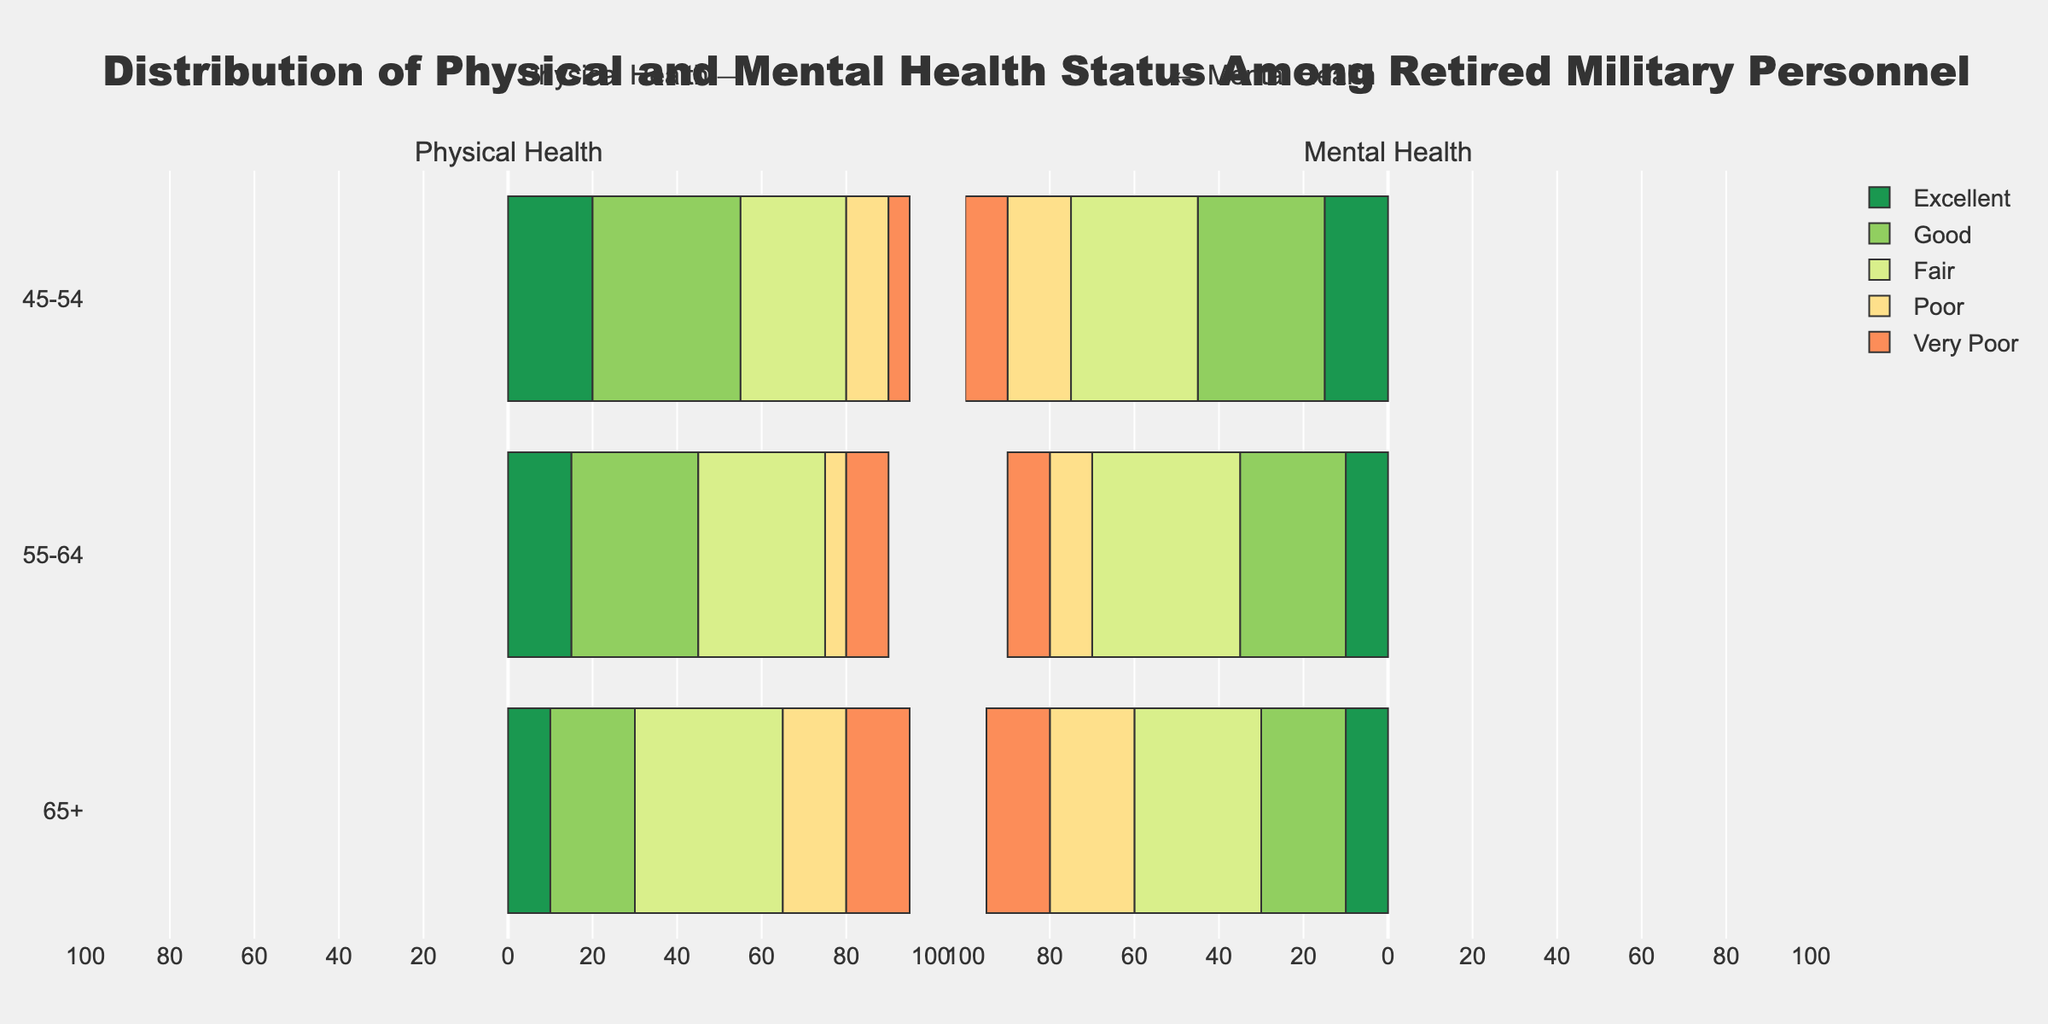What's the percentage of retired personnel aged 55-64 with very poor physical health? Look at the bar section corresponding to the 55-64 age group on the left side (physical health) and locate the "Very Poor" segment. The percentage next to it shows 10%.
Answer: 10% Which age group has the highest percentage of retired personnel with excellent mental health? Compare the "Excellent Mental" segments across all age groups on the right side (mental health). The 45-54 age group has the highest percentage at 15%.
Answer: 45-54 Is the percentage of retired personnel aged 65+ with poor mental health higher or lower than the percentage with poor physical health? Compare the "Poor" segments for the 65+ age group on both sides of the chart. The mental health side shows 25%, while the physical health side shows 20%. Therefore, the percentage of poor mental health is higher.
Answer: Higher What is the total percentage of retired personnel aged 45-54 with fair or poor physical health? Add the percentages of the "Fair Physical" and "Poor Physical" segments for the 45-54 age group. Fair is 25% and Poor is 10%, so the total is 25% + 10% = 35%.
Answer: 35% Which health status has the smallest combined percentage for both physical and mental health in the 55-64 age group? Sum the percentages for "Excellent", "Good", "Fair", "Poor", and "Very Poor" for both physical and mental health in the 55-64 age group. "Excellent": 15%+10%=25%, "Good": 30%+25%=55%, "Fair": 30%+35%=65%, "Poor": 15%+20%=35%, "Very Poor": 10%+10%=20%. The smallest combined percentage is for "Very Poor" at 20%.
Answer: Very Poor What's the trend in the percentage of retired personnel with good physical health as they age? Examine the "Good Physical" segments across the age groups. The percentages decrease with age: 45-54 (35%), 55-64 (30%), and 65+ (20%). This indicates a downward trend.
Answer: Downward If you combine the percentages of poor and very poor mental health for the 65+ age group, how do these compare to the total percentage of excellent and good physical health in the same group? Add "Poor Mental" (25%) and "Very Poor Mental" (15%) for 65+: 25% + 15% = 40%. Then, add "Excellent Physical" (10%) and "Good Physical" (20%) for 65+: 10% + 20% = 30%. Poor and very poor mental health combined (40%) are greater than excellent and good physical health combined (30%).
Answer: Greater Which age group has the overall lowest percentage of very poor health (physical or mental)? Identify the "Very Poor" segments across both sides for each age group, and determine the lowest total percentage. For 45-54: 5% (physical) + 10% (mental) = 15%, for 55-64: 10% (physical) + 10% (mental) = 20%, for 65+: 15% (physical) + 15% (mental) = 30%. The 45-54 group has the lowest combined percentage of 15%.
Answer: 45-54 In which age group is the portion of personnel with good mental health the highest? Look at the "Good Mental" segments across all age groups on the right side (mental health) and identify the highest percentage. The 45-54 age group has the highest percentage with 30%.
Answer: 45-54 